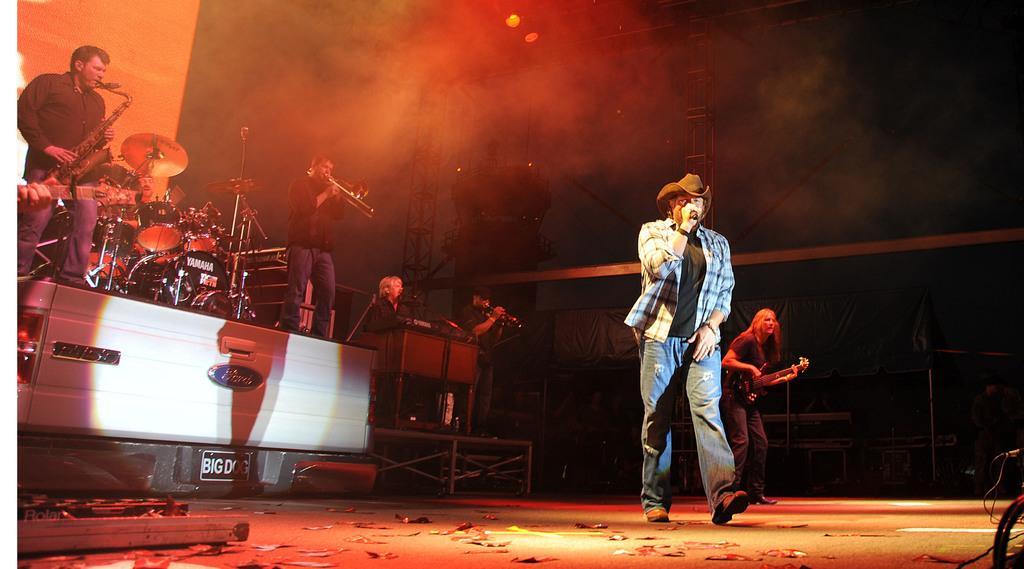Could you give a brief overview of what you see in this image? In this image, we can see a musical band. There are some persons wearing clothes and playing musical instruments. There are musical drums on the vehicle which on the left side of the image. There is an another person in the middle of the image wearing hat and holding a mic with her hand. There are lights at the top of the image. 